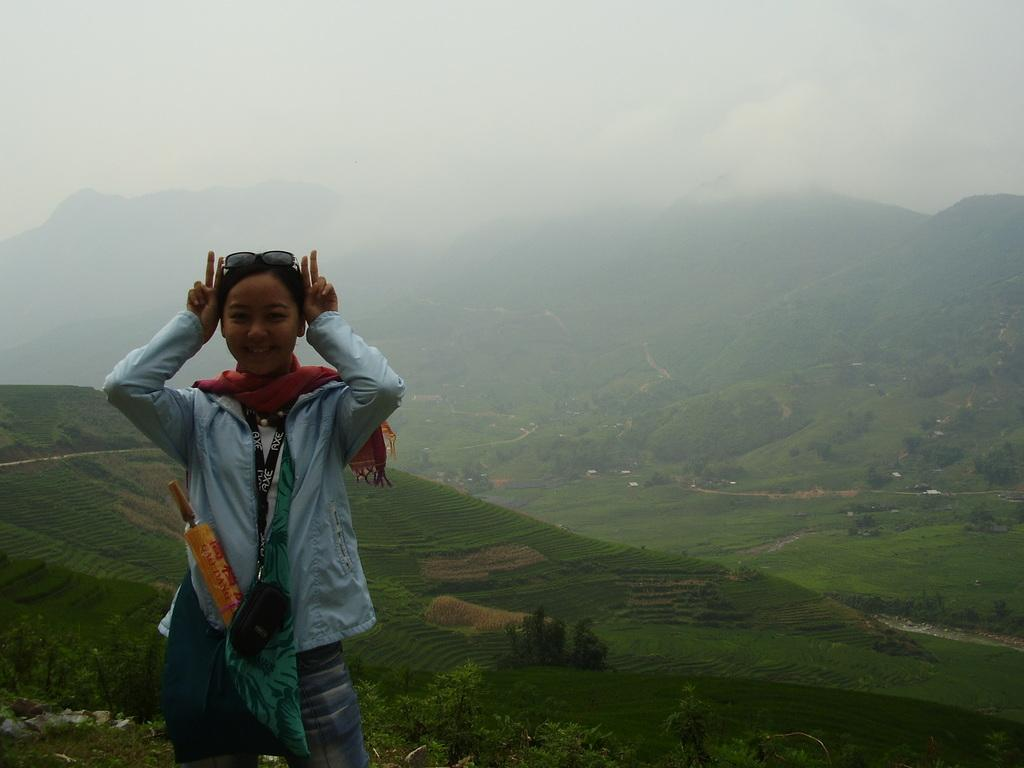What is the main subject of the image? There is a lady standing in the image. What can be seen in the background of the image? There are mountains, trees, and fog in the background of the image. What type of mask is the lady wearing in the image? There is no mask visible on the lady in the image. What color is the skirt that the lady is wearing in the image? There is no skirt visible on the lady in the image. 